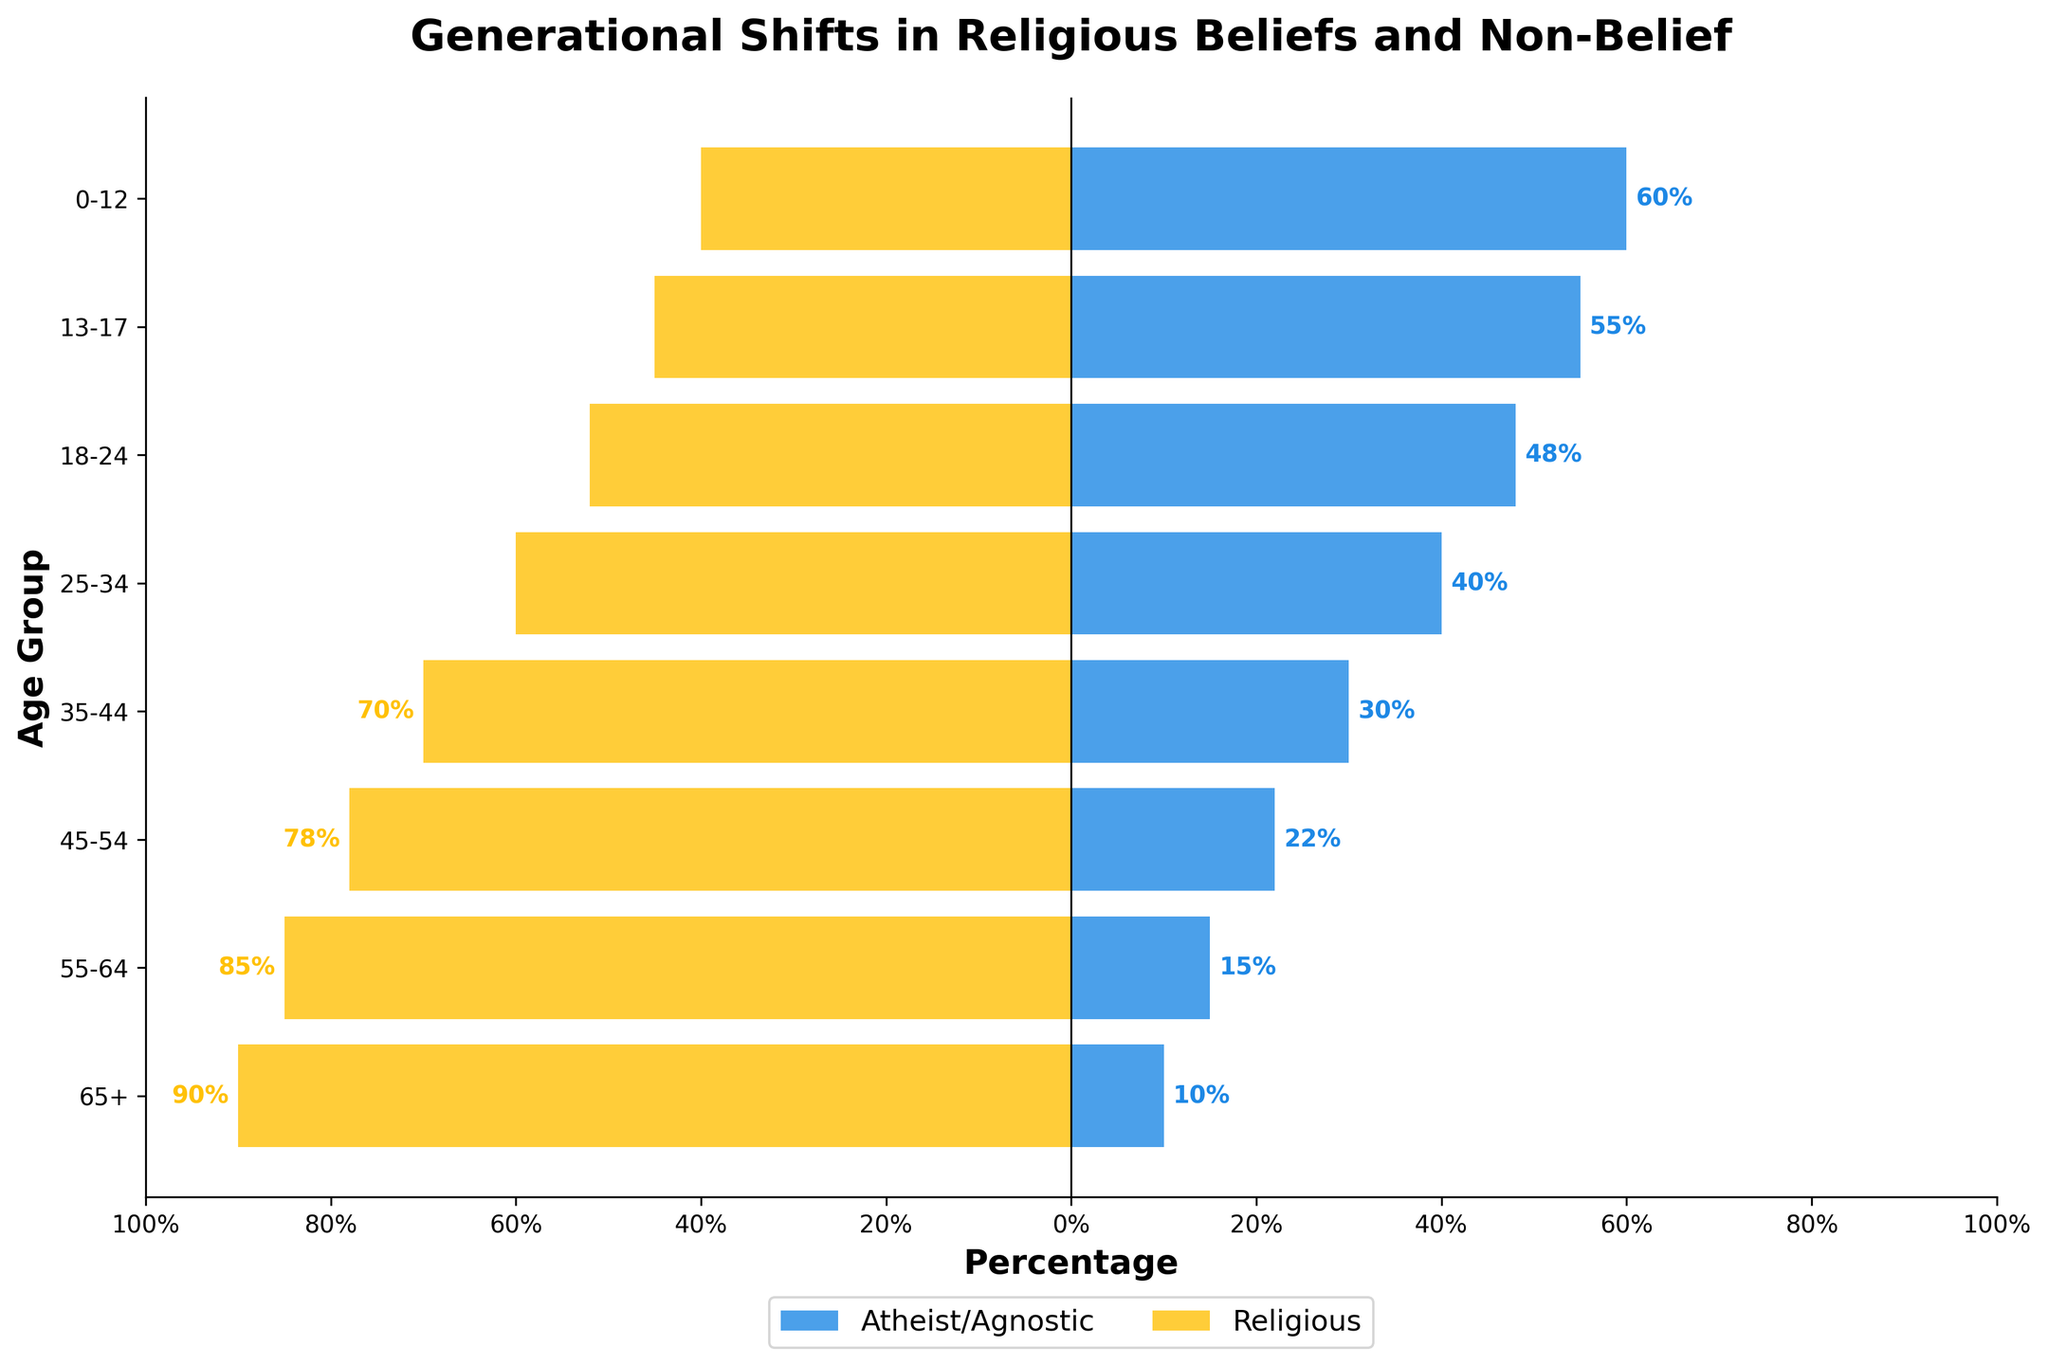What's the title of the figure? The title of the figure is prominently displayed at the top, reading "Generational Shifts in Religious Beliefs and Non-Belief."
Answer: Generational Shifts in Religious Beliefs and Non-Belief How is the percentage of the 65+ age group distributed between Atheist/Agnostic and Religious? The 65+ age group has 10% identifying as Atheist/Agnostic and 90% as Religious, as shown by the length of each bar corresponding to this age group.
Answer: 10% Atheist/Agnostic, 90% Religious Which age group has the highest percentage of Atheist/Agnostic individuals? The age group with the highest percentage of Atheist/Agnostic individuals is the 0-12 age group, indicated by the longest Atheist/Agnostic bar.
Answer: 0-12 What's the overall trend in religious belief as age decreases? As age decreases, the percentage of individuals identifying as Atheist/Agnostic increases, while the percentage of Religious individuals decreases. This is observed by the shift in bar lengths across the age groups from 65+ to 0-12.
Answer: Increasing Atheist/Agnostic, decreasing Religious How much greater is the percentage of Atheist/Agnostic individuals in the 25-34 age group than in the 45-54 age group? The percentage of Atheist/Agnostic individuals in the 25-34 age group is 40%, and in the 45-54 age group, it is 22%. The difference is calculated as 40% - 22% = 18%.
Answer: 18% Which age group has the lowest percentage of Religious individuals? The age group with the lowest percentage of Religious individuals is the 0-12 age group, as indicated by the smallest Religious bar length of 40%.
Answer: 0-12 What's the combined percentage of Religious individuals in the 18-24 and 25-34 age groups? The percentage of Religious individuals is 52% for the 18-24 age group and 60% for the 25-34 age group. The combined percentage is 52% + 60% = 112%.
Answer: 112% How does the proportion of Atheist/Agnostic individuals in the 55-64 age group compare to the 35-44 age group? The proportion of Atheist/Agnostic individuals in the 55-64 age group is 15%, whereas in the 35-44 age group, it is 30%. Therefore, the percentage in the 35-44 group is twice that in the 55-64 group.
Answer: 35-44 group > 55-64 group What is the percentage difference in Religious individuals between the 13-17 and 0-12 age groups? The percentage of Religious individuals in the 13-17 age group is 45%, and in the 0-12 age group, it is 40%. The difference is calculated as 45% - 40% = 5%.
Answer: 5% 